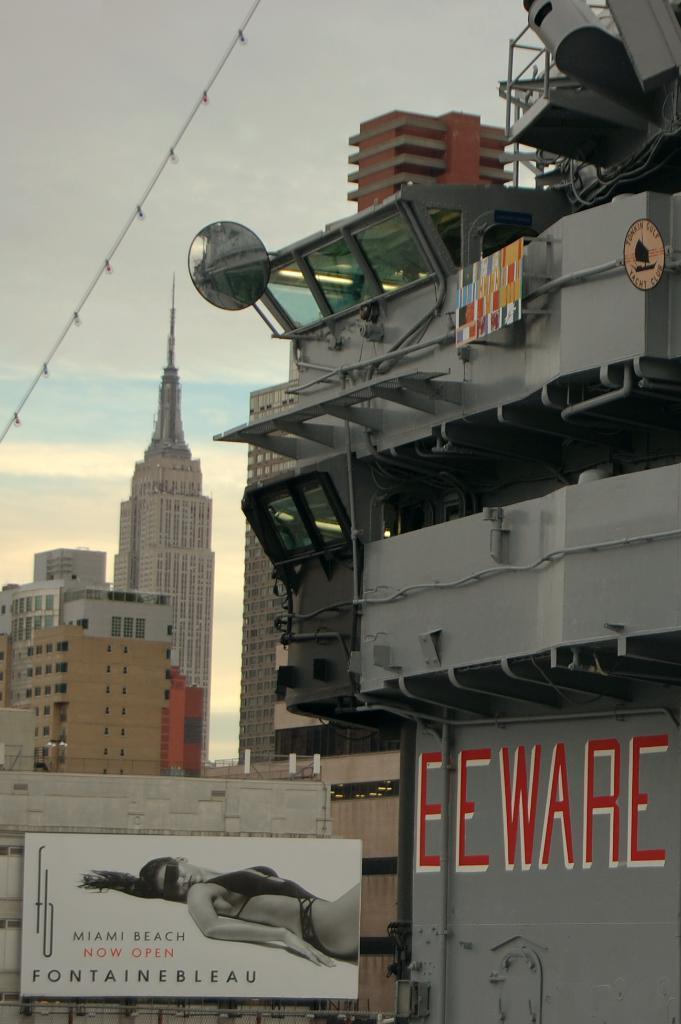Can you describe this image briefly? In this image, we can see so many buildings, glass, rods, pipes, hoarding, some objects. Background there is a sky. 